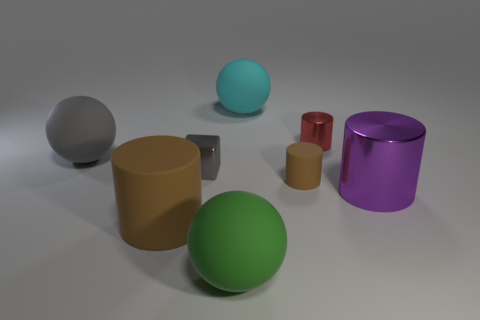Is there any indication of the scale or size of the objects relative to a real-world object? Without a familiar object for size comparison, it is difficult to determine the exact scale of the objects, but they are depicted with relative sizes to each other, suggesting a variety of dimensions. 